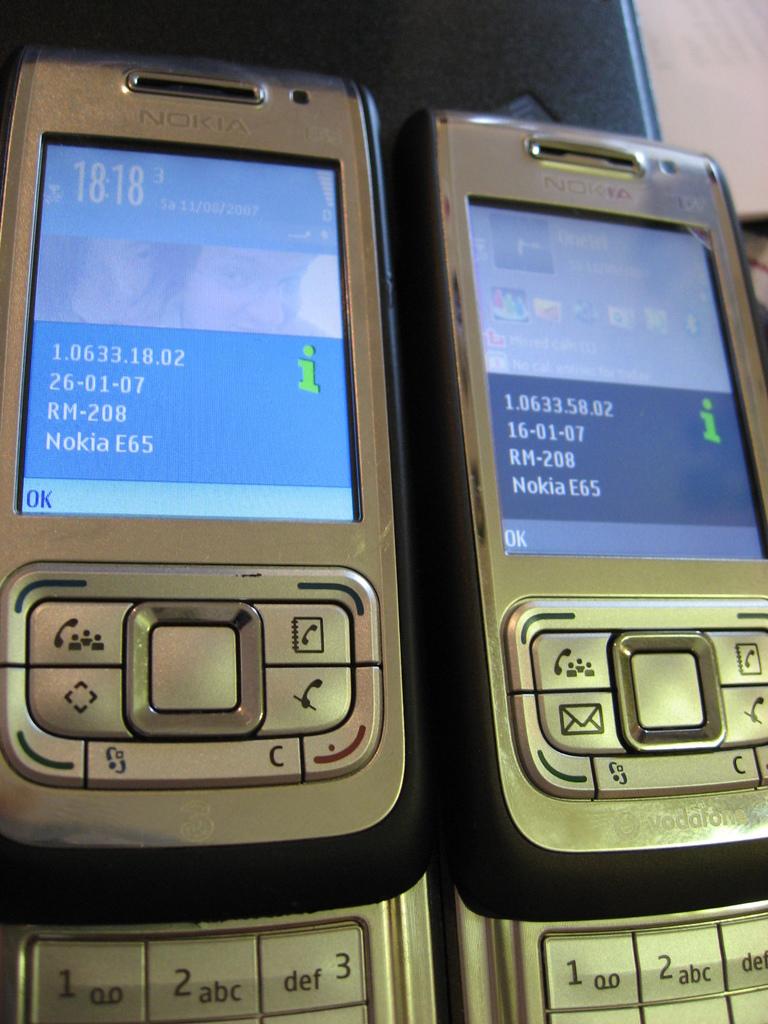What date is displayed on  the left phone?
Your answer should be compact. 26-01-07. What is the green letter?
Your response must be concise. I. 